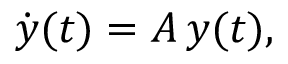Convert formula to latex. <formula><loc_0><loc_0><loc_500><loc_500>\dot { y } ( t ) = A \, y ( t ) ,</formula> 